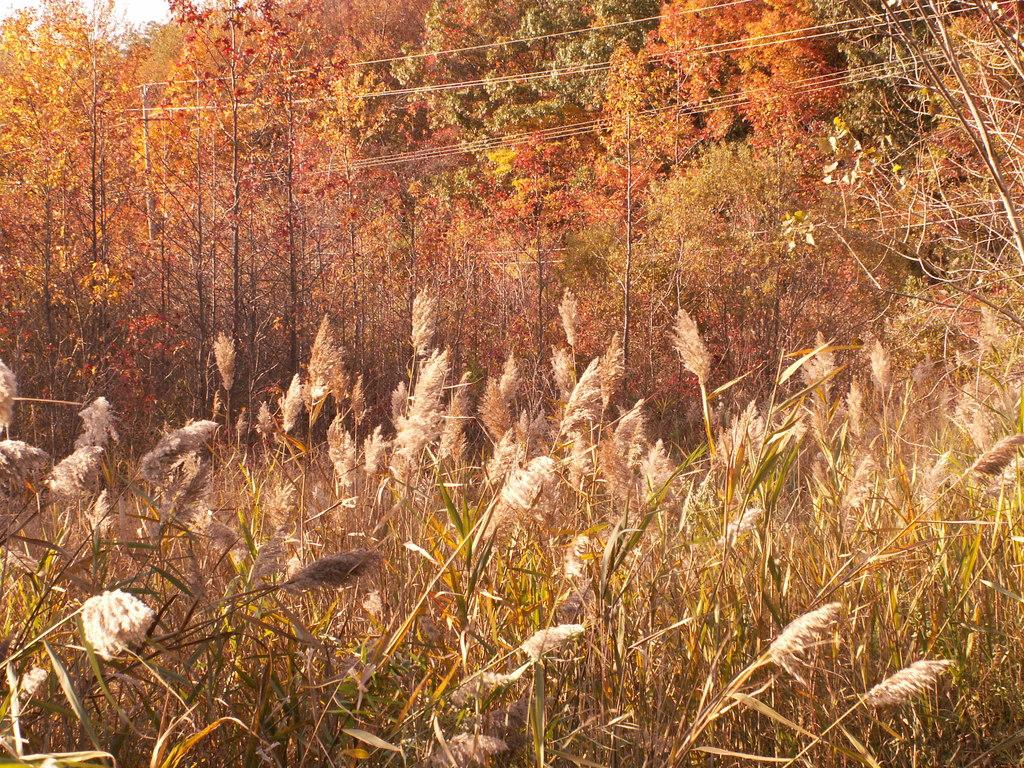What type of vegetation can be seen in the image? There are trees in the image. What else can be seen on the ground in the image? There is grass in the image. What else is present in the image besides vegetation? There are cables in the image. What part of the natural environment is visible in the image? The sky is visible at the top left corner of the image. Can you describe the haircut of the bird in the image? There are no birds present in the image, and therefore no haircuts to describe. What color is the sock on the tree in the image? There are no socks present in the image, and socks are not typically found on trees. 